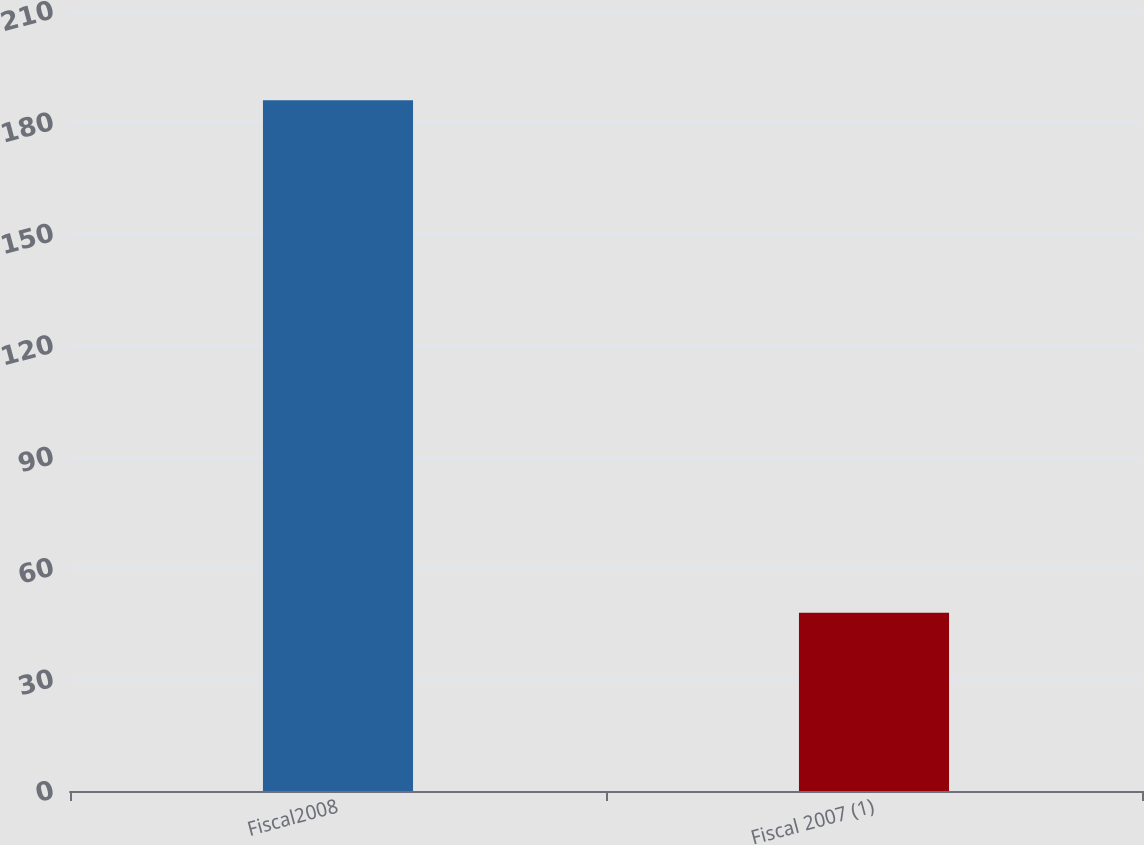<chart> <loc_0><loc_0><loc_500><loc_500><bar_chart><fcel>Fiscal2008<fcel>Fiscal 2007 (1)<nl><fcel>186<fcel>48<nl></chart> 